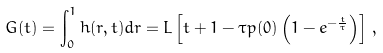<formula> <loc_0><loc_0><loc_500><loc_500>G ( t ) = \int _ { 0 } ^ { 1 } h ( r , t ) d r = L \left [ t + 1 - \tau p ( 0 ) \left ( 1 - e ^ { - \frac { t } { \tau } } \right ) \right ] \, ,</formula> 